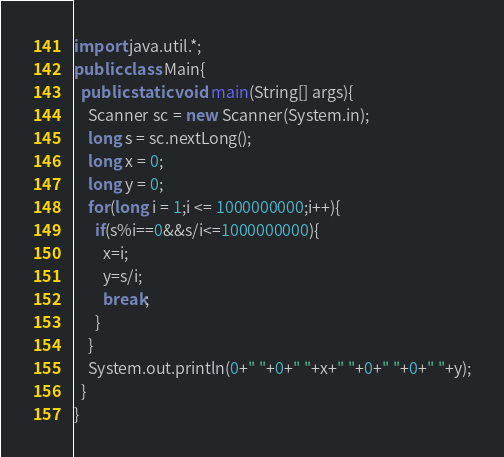<code> <loc_0><loc_0><loc_500><loc_500><_Java_>import java.util.*;
public class Main{
  public static void main(String[] args){
    Scanner sc = new Scanner(System.in);
    long s = sc.nextLong();
    long x = 0;
    long y = 0;
    for(long i = 1;i <= 1000000000;i++){
      if(s%i==0&&s/i<=1000000000){
        x=i;
        y=s/i;
        break;
      }
    }
    System.out.println(0+" "+0+" "+x+" "+0+" "+0+" "+y);
  }
}</code> 